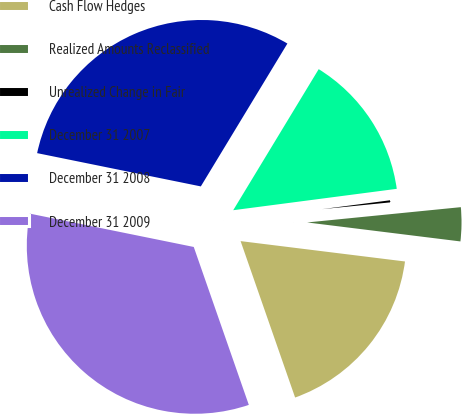Convert chart to OTSL. <chart><loc_0><loc_0><loc_500><loc_500><pie_chart><fcel>Cash Flow Hedges<fcel>Realized Amounts Reclassified<fcel>Unrealized Change in Fair<fcel>December 31 2007<fcel>December 31 2008<fcel>December 31 2009<nl><fcel>17.7%<fcel>3.54%<fcel>0.49%<fcel>14.26%<fcel>30.48%<fcel>33.53%<nl></chart> 